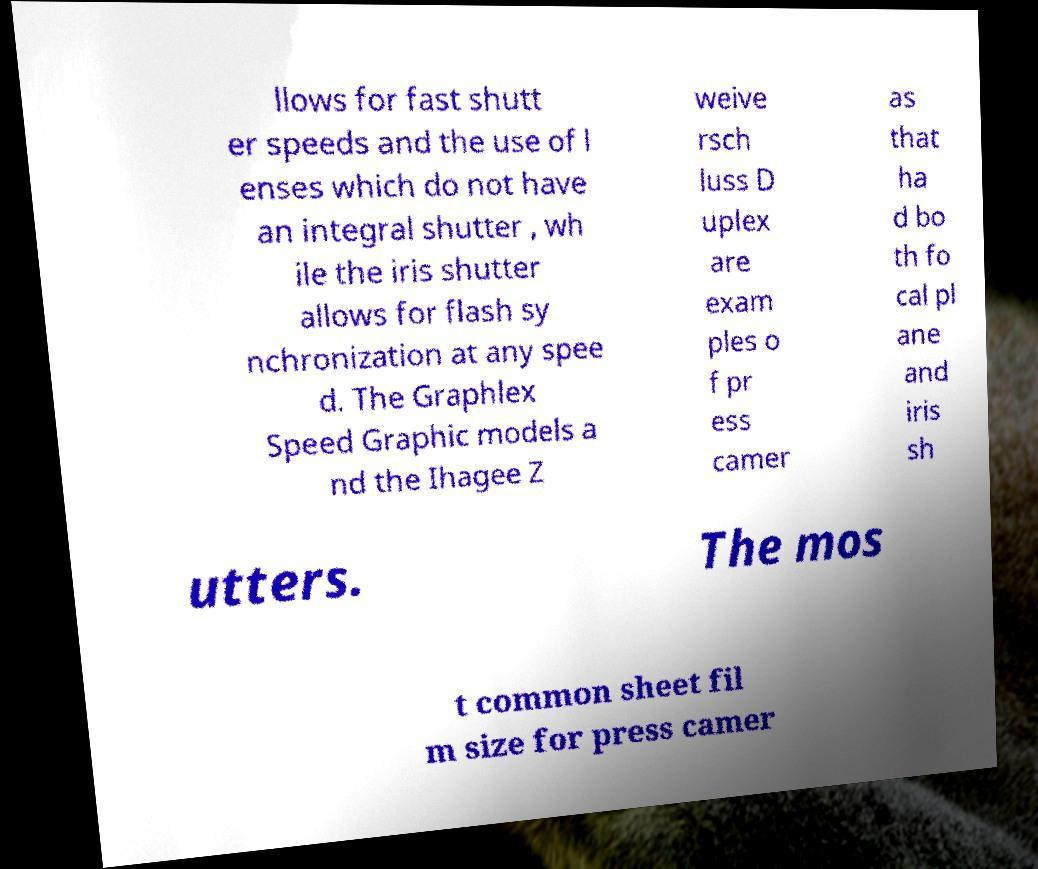There's text embedded in this image that I need extracted. Can you transcribe it verbatim? llows for fast shutt er speeds and the use of l enses which do not have an integral shutter , wh ile the iris shutter allows for flash sy nchronization at any spee d. The Graphlex Speed Graphic models a nd the Ihagee Z weive rsch luss D uplex are exam ples o f pr ess camer as that ha d bo th fo cal pl ane and iris sh utters. The mos t common sheet fil m size for press camer 